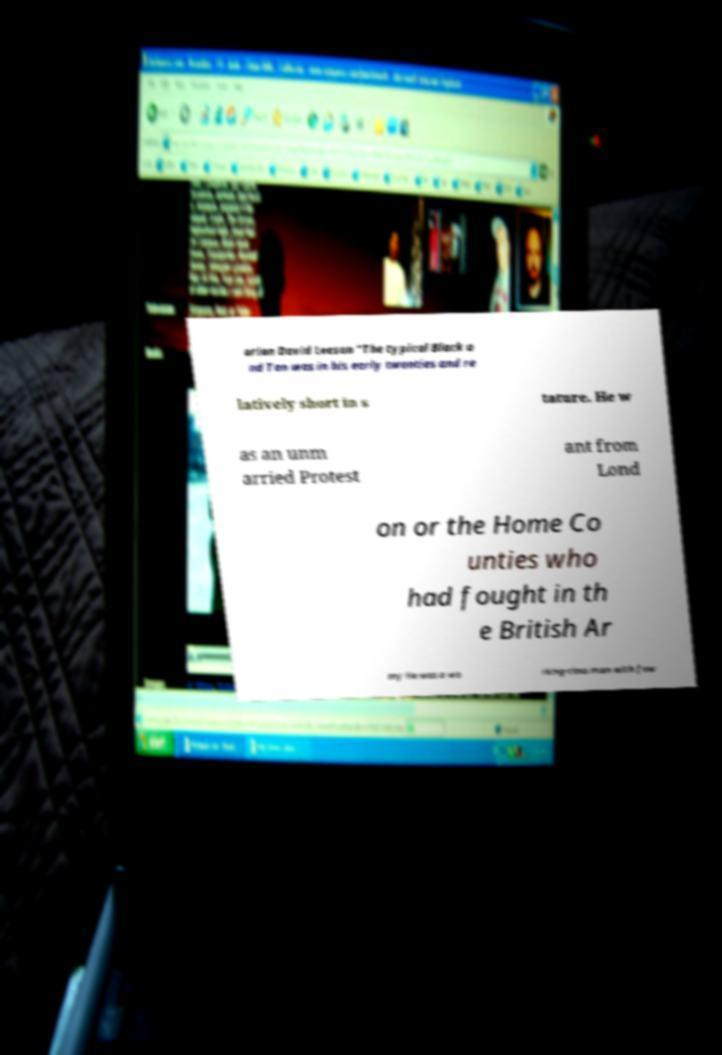What messages or text are displayed in this image? I need them in a readable, typed format. orian David Leeson "The typical Black a nd Tan was in his early twenties and re latively short in s tature. He w as an unm arried Protest ant from Lond on or the Home Co unties who had fought in th e British Ar my He was a wo rking-class man with few 